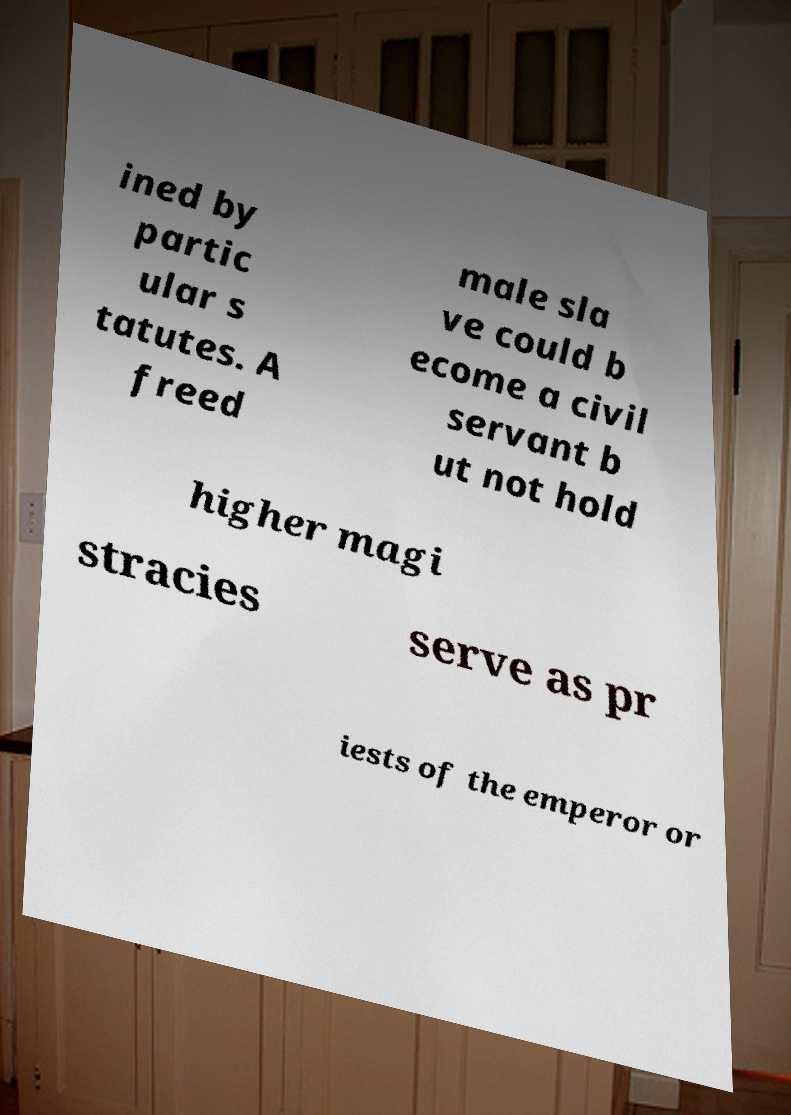I need the written content from this picture converted into text. Can you do that? ined by partic ular s tatutes. A freed male sla ve could b ecome a civil servant b ut not hold higher magi stracies serve as pr iests of the emperor or 